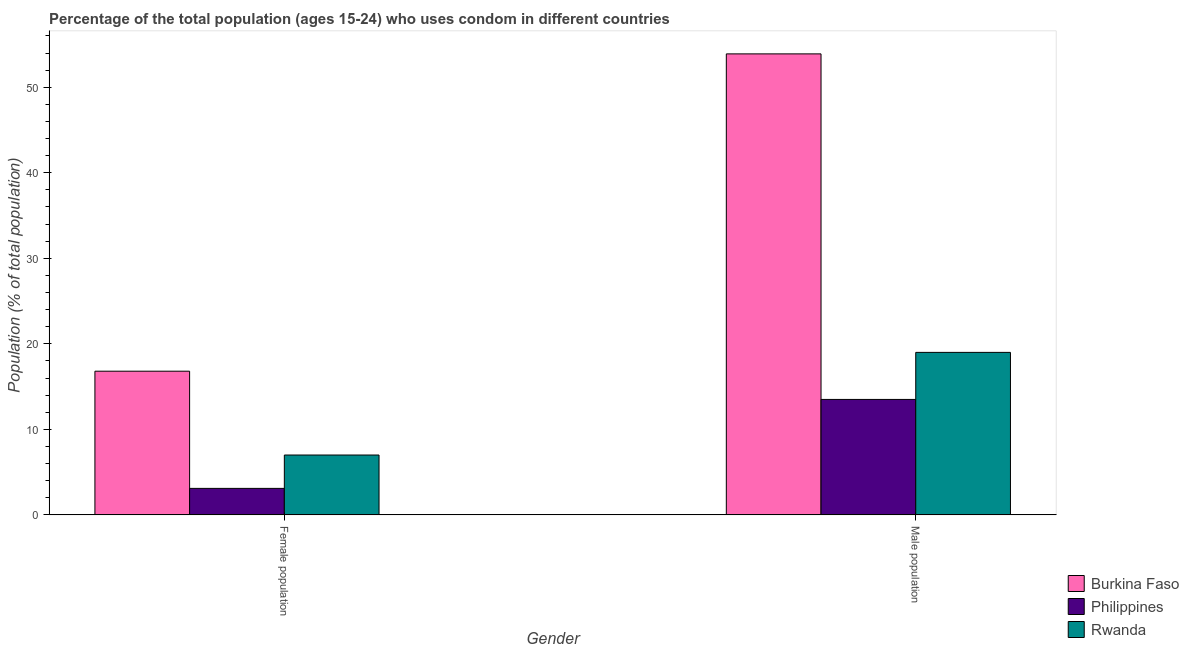Are the number of bars per tick equal to the number of legend labels?
Your answer should be compact. Yes. What is the label of the 1st group of bars from the left?
Keep it short and to the point. Female population. What is the male population in Rwanda?
Your response must be concise. 19. Across all countries, what is the maximum male population?
Make the answer very short. 53.9. Across all countries, what is the minimum female population?
Give a very brief answer. 3.1. In which country was the female population maximum?
Offer a terse response. Burkina Faso. What is the total male population in the graph?
Your answer should be very brief. 86.4. What is the difference between the female population in Rwanda and the male population in Burkina Faso?
Your response must be concise. -46.9. What is the average female population per country?
Keep it short and to the point. 8.97. What is the difference between the male population and female population in Rwanda?
Offer a terse response. 12. What is the ratio of the male population in Rwanda to that in Philippines?
Offer a very short reply. 1.41. What does the 2nd bar from the left in Female population represents?
Provide a short and direct response. Philippines. What does the 1st bar from the right in Female population represents?
Your answer should be compact. Rwanda. What is the difference between two consecutive major ticks on the Y-axis?
Provide a short and direct response. 10. Where does the legend appear in the graph?
Ensure brevity in your answer.  Bottom right. How many legend labels are there?
Your answer should be compact. 3. What is the title of the graph?
Offer a very short reply. Percentage of the total population (ages 15-24) who uses condom in different countries. What is the label or title of the X-axis?
Offer a terse response. Gender. What is the label or title of the Y-axis?
Your answer should be very brief. Population (% of total population) . What is the Population (% of total population)  of Burkina Faso in Female population?
Ensure brevity in your answer.  16.8. What is the Population (% of total population)  of Philippines in Female population?
Offer a very short reply. 3.1. What is the Population (% of total population)  of Rwanda in Female population?
Your answer should be very brief. 7. What is the Population (% of total population)  of Burkina Faso in Male population?
Your answer should be compact. 53.9. What is the Population (% of total population)  in Philippines in Male population?
Make the answer very short. 13.5. Across all Gender, what is the maximum Population (% of total population)  in Burkina Faso?
Keep it short and to the point. 53.9. Across all Gender, what is the maximum Population (% of total population)  in Philippines?
Make the answer very short. 13.5. Across all Gender, what is the maximum Population (% of total population)  of Rwanda?
Provide a short and direct response. 19. Across all Gender, what is the minimum Population (% of total population)  in Rwanda?
Provide a succinct answer. 7. What is the total Population (% of total population)  of Burkina Faso in the graph?
Your response must be concise. 70.7. What is the total Population (% of total population)  of Philippines in the graph?
Offer a very short reply. 16.6. What is the total Population (% of total population)  in Rwanda in the graph?
Make the answer very short. 26. What is the difference between the Population (% of total population)  in Burkina Faso in Female population and that in Male population?
Offer a very short reply. -37.1. What is the difference between the Population (% of total population)  of Burkina Faso in Female population and the Population (% of total population)  of Philippines in Male population?
Offer a very short reply. 3.3. What is the difference between the Population (% of total population)  in Philippines in Female population and the Population (% of total population)  in Rwanda in Male population?
Provide a succinct answer. -15.9. What is the average Population (% of total population)  in Burkina Faso per Gender?
Offer a very short reply. 35.35. What is the difference between the Population (% of total population)  in Burkina Faso and Population (% of total population)  in Rwanda in Female population?
Offer a terse response. 9.8. What is the difference between the Population (% of total population)  of Burkina Faso and Population (% of total population)  of Philippines in Male population?
Your answer should be very brief. 40.4. What is the difference between the Population (% of total population)  of Burkina Faso and Population (% of total population)  of Rwanda in Male population?
Your answer should be compact. 34.9. What is the ratio of the Population (% of total population)  of Burkina Faso in Female population to that in Male population?
Offer a terse response. 0.31. What is the ratio of the Population (% of total population)  in Philippines in Female population to that in Male population?
Give a very brief answer. 0.23. What is the ratio of the Population (% of total population)  of Rwanda in Female population to that in Male population?
Provide a succinct answer. 0.37. What is the difference between the highest and the second highest Population (% of total population)  in Burkina Faso?
Your response must be concise. 37.1. What is the difference between the highest and the second highest Population (% of total population)  of Philippines?
Offer a very short reply. 10.4. What is the difference between the highest and the lowest Population (% of total population)  in Burkina Faso?
Your answer should be compact. 37.1. What is the difference between the highest and the lowest Population (% of total population)  of Philippines?
Provide a short and direct response. 10.4. What is the difference between the highest and the lowest Population (% of total population)  of Rwanda?
Offer a terse response. 12. 